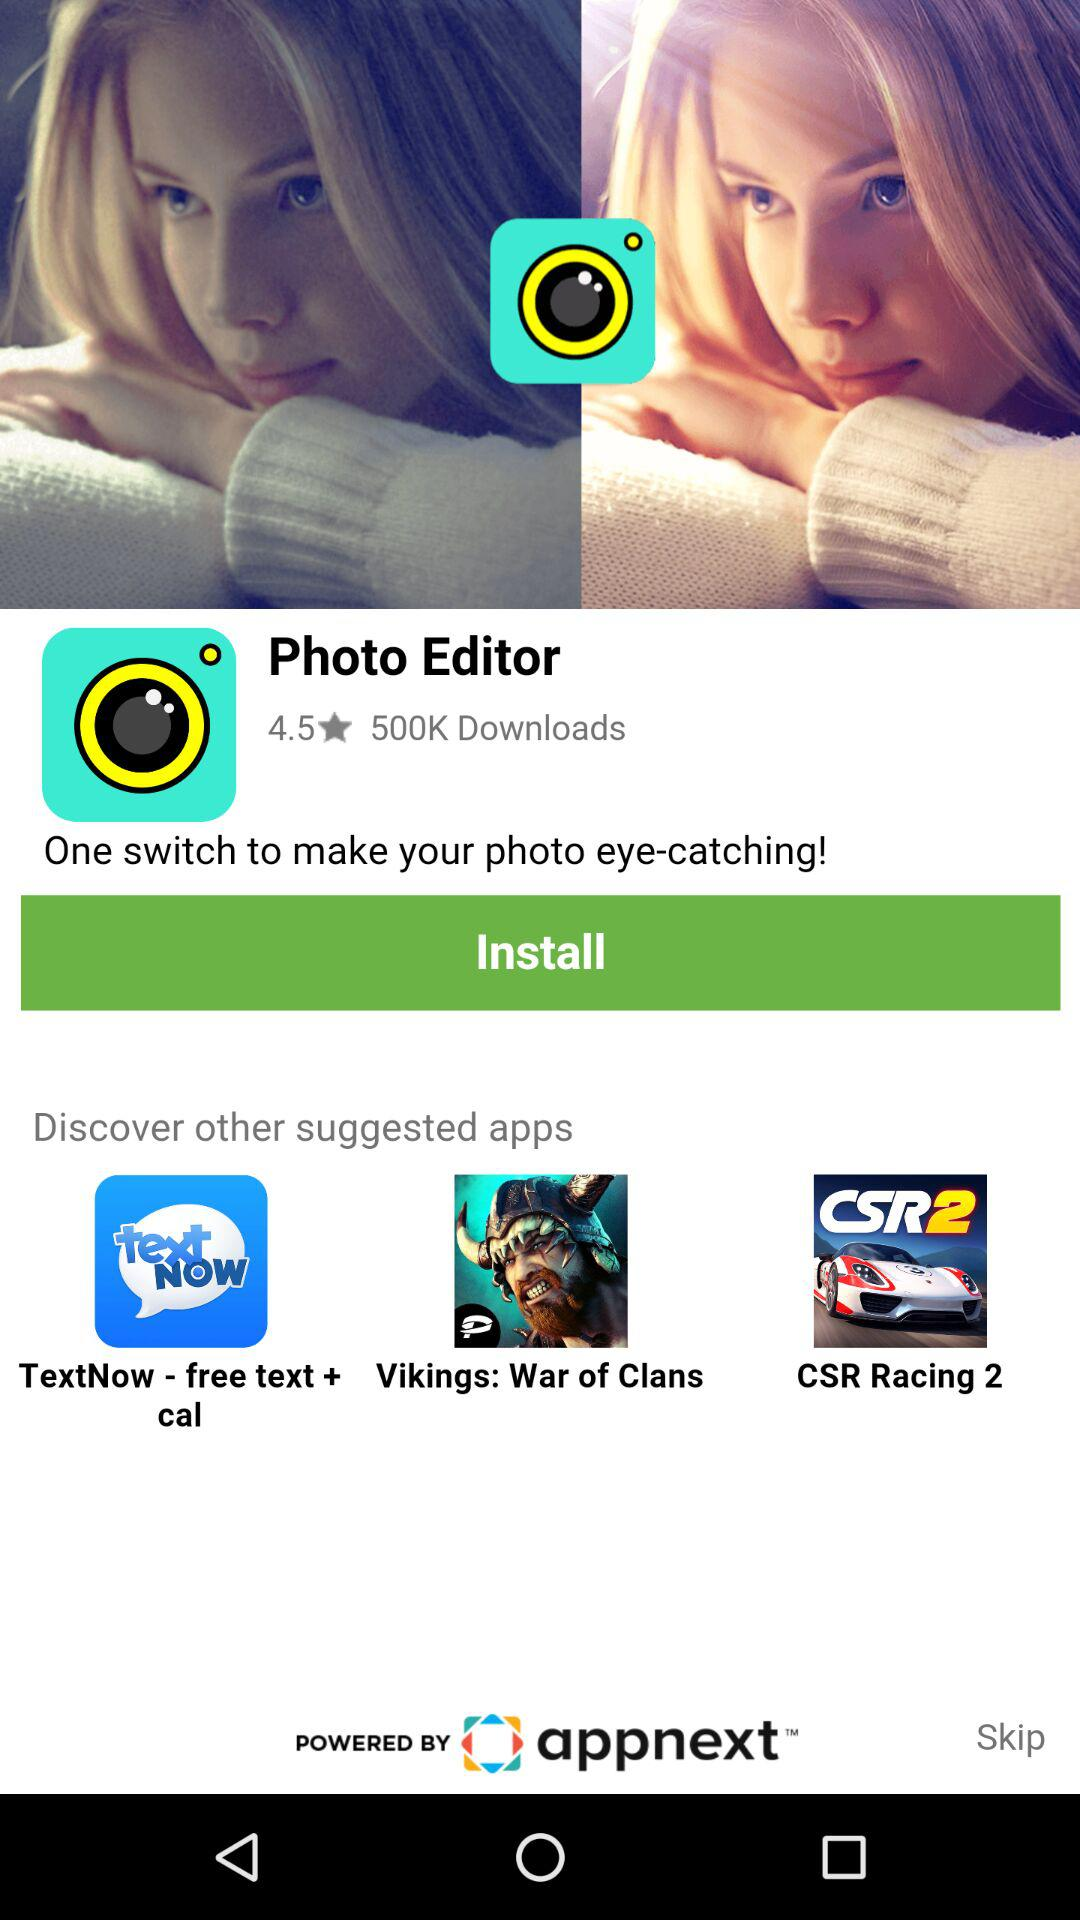What is the rating? The rating is 4.5 stars. 